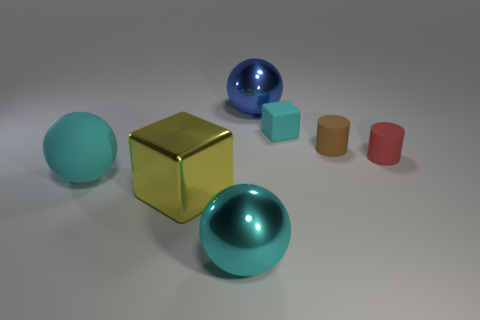There is a small cube; does it have the same color as the matte thing in front of the tiny red cylinder?
Ensure brevity in your answer.  Yes. What number of balls are brown things or blue shiny things?
Provide a short and direct response. 1. There is another ball that is made of the same material as the blue ball; what color is it?
Offer a terse response. Cyan. There is a ball in front of the metallic block; does it have the same size as the large cyan rubber thing?
Provide a short and direct response. Yes. Is the material of the small block the same as the cyan sphere in front of the shiny block?
Offer a terse response. No. What color is the metal ball in front of the metallic cube?
Make the answer very short. Cyan. There is a brown object that is behind the red rubber thing; is there a tiny cyan object that is to the right of it?
Provide a succinct answer. No. Is the color of the block behind the big rubber ball the same as the sphere that is in front of the big yellow metal block?
Provide a short and direct response. Yes. What number of cylinders are behind the cyan rubber cube?
Keep it short and to the point. 0. What number of other things have the same color as the large rubber thing?
Keep it short and to the point. 2. 